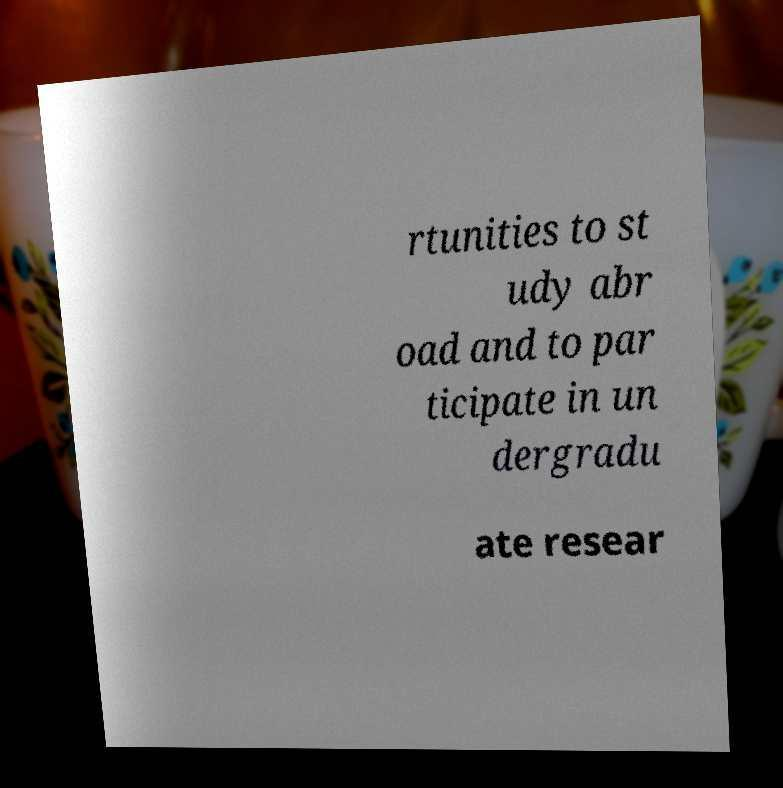Please read and relay the text visible in this image. What does it say? rtunities to st udy abr oad and to par ticipate in un dergradu ate resear 